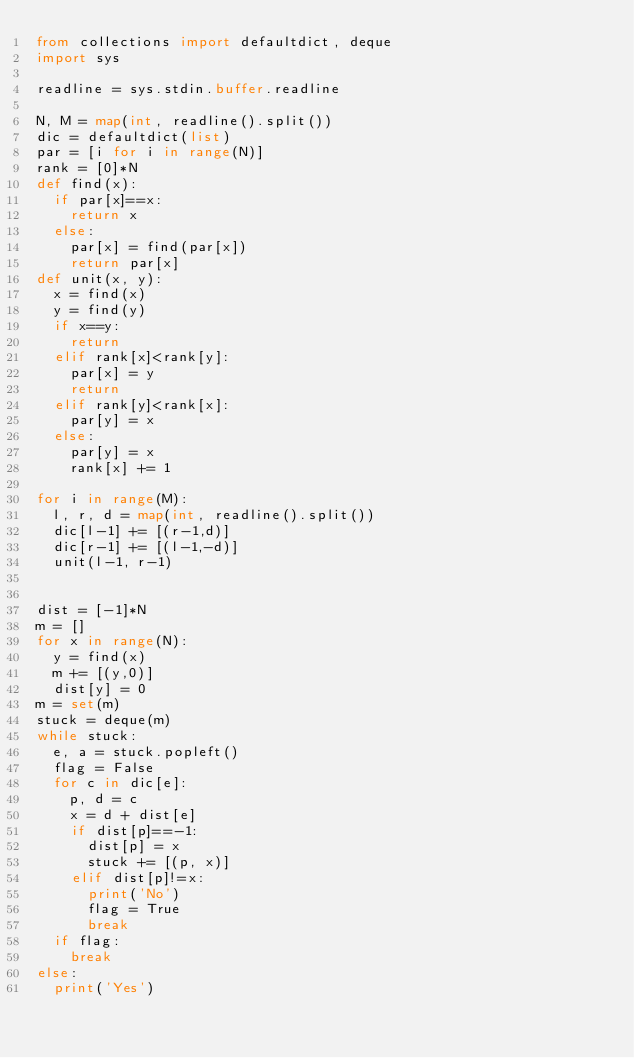Convert code to text. <code><loc_0><loc_0><loc_500><loc_500><_Python_>from collections import defaultdict, deque
import sys

readline = sys.stdin.buffer.readline

N, M = map(int, readline().split())
dic = defaultdict(list)
par = [i for i in range(N)]
rank = [0]*N
def find(x):
  if par[x]==x:
    return x
  else:
    par[x] = find(par[x])
    return par[x]
def unit(x, y):
  x = find(x)
  y = find(y)
  if x==y:
    return
  elif rank[x]<rank[y]:
    par[x] = y
    return
  elif rank[y]<rank[x]:
    par[y] = x
  else:
    par[y] = x
    rank[x] += 1

for i in range(M):
  l, r, d = map(int, readline().split())
  dic[l-1] += [(r-1,d)]
  dic[r-1] += [(l-1,-d)]
  unit(l-1, r-1)


dist = [-1]*N
m = []
for x in range(N):
  y = find(x)
  m += [(y,0)]
  dist[y] = 0
m = set(m)
stuck = deque(m)
while stuck:
  e, a = stuck.popleft()
  flag = False
  for c in dic[e]:
    p, d = c
    x = d + dist[e]
    if dist[p]==-1:
      dist[p] = x
      stuck += [(p, x)]
    elif dist[p]!=x:
      print('No')
      flag = True
      break
  if flag:
    break
else:
  print('Yes')</code> 